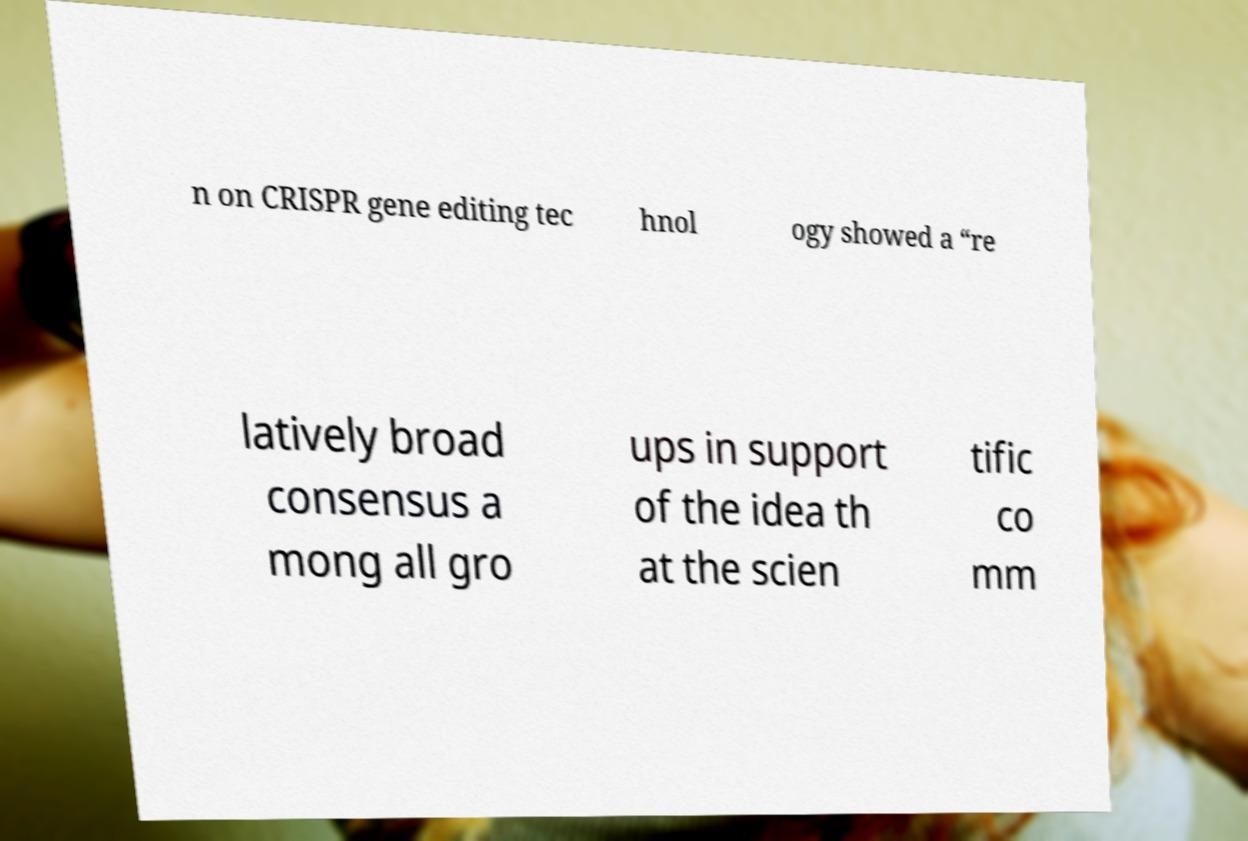For documentation purposes, I need the text within this image transcribed. Could you provide that? n on CRISPR gene editing tec hnol ogy showed a “re latively broad consensus a mong all gro ups in support of the idea th at the scien tific co mm 